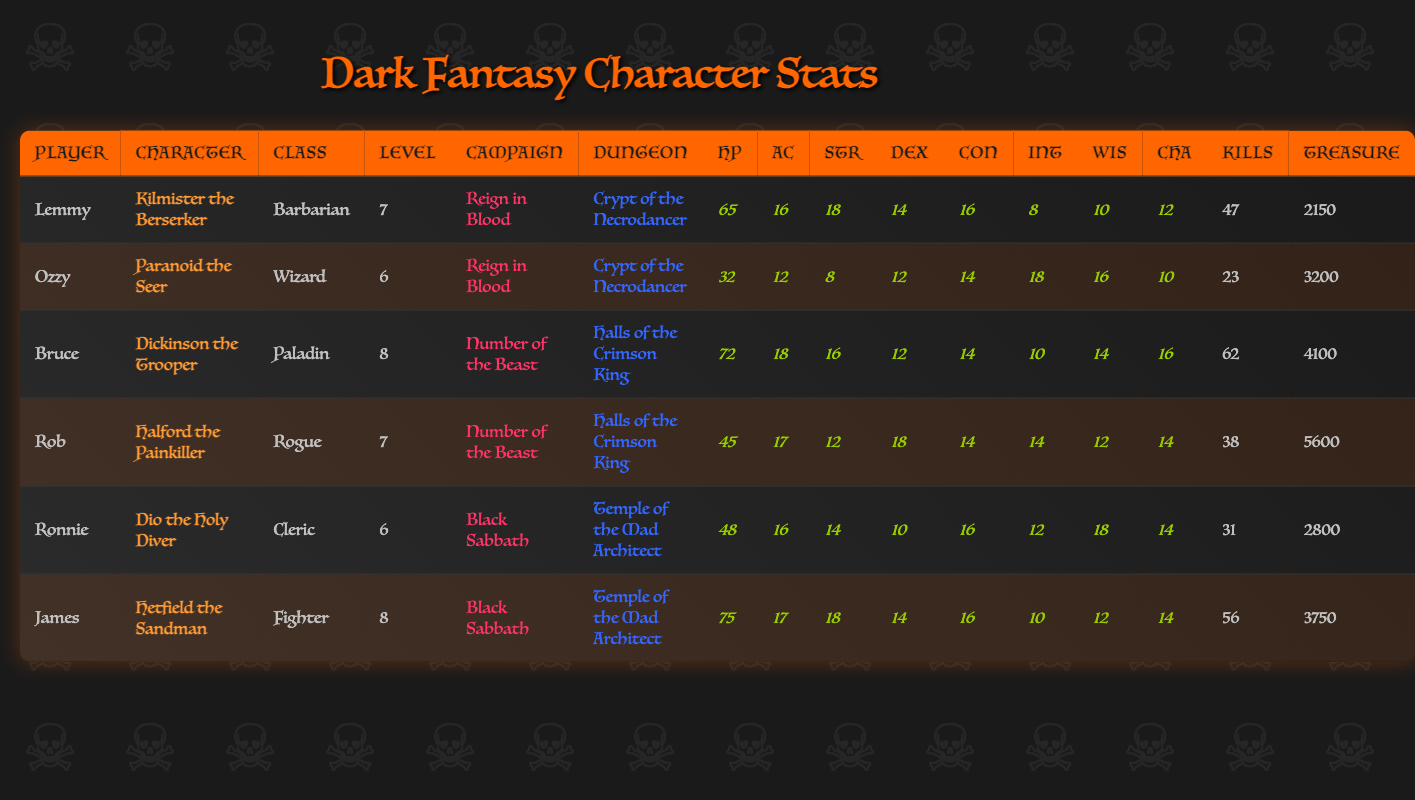What is the maximum hit points (HP) among the characters? By reviewing the HP column, we find the highest value is 75, associated with Hetfield the Sandman.
Answer: 75 Who has the highest armor class (AC)? Looking through the AC column, we see that Dickinson the Trooper has the highest AC of 18.
Answer: Dickinson the Trooper How many total kills did Kilmister the Berserker achieve? The total kills for Kilmister the Berserker is clearly stated in the table as 47.
Answer: 47 What is the total treasure found by all characters combined? To find the total treasure, we add up the treasure found by all characters: 2150 + 3200 + 4100 + 5600 + 2800 + 3750 = 18600.
Answer: 18600 Is there a character with both a strength score and a dexterity score above 15? Scanning the strength and dexterity scores, we note that both Hetfield the Sandman and Halford the Painkiller have scores (Strength: 18, Dexterity: 18 for Hetfield; Strength: 12, Dexterity: 18 for Halford) where at least one score is above 15. Thus, the answer is yes.
Answer: Yes Who found the most treasure, and how much did they find? By inspecting the treasure found column, we see that Halford the Painkiller found the most treasure, which is 5600.
Answer: Halford the Painkiller, 5600 On average, what is the level of characters in the "Reign in Blood" campaign? The levels of characters in this campaign (7 and 6) sum to 13 across 2 characters. Dividing this sum by 2 gives an average level of 6.5.
Answer: 6.5 Which character has a higher intelligence score, Kilmister the Berserker or Dio the Holy Diver? Kilmister has an intelligence score of 8 while Dio has a score of 12. Since 12 is greater than 8, the answer is Dio the Holy Diver has a higher intelligence.
Answer: Dio the Holy Diver What is the total kills for characters in the "Black Sabbath" campaign? The total of kills in "Black Sabbath" (31 from Dio + 56 from Hetfield) is 87 when we add them together.
Answer: 87 